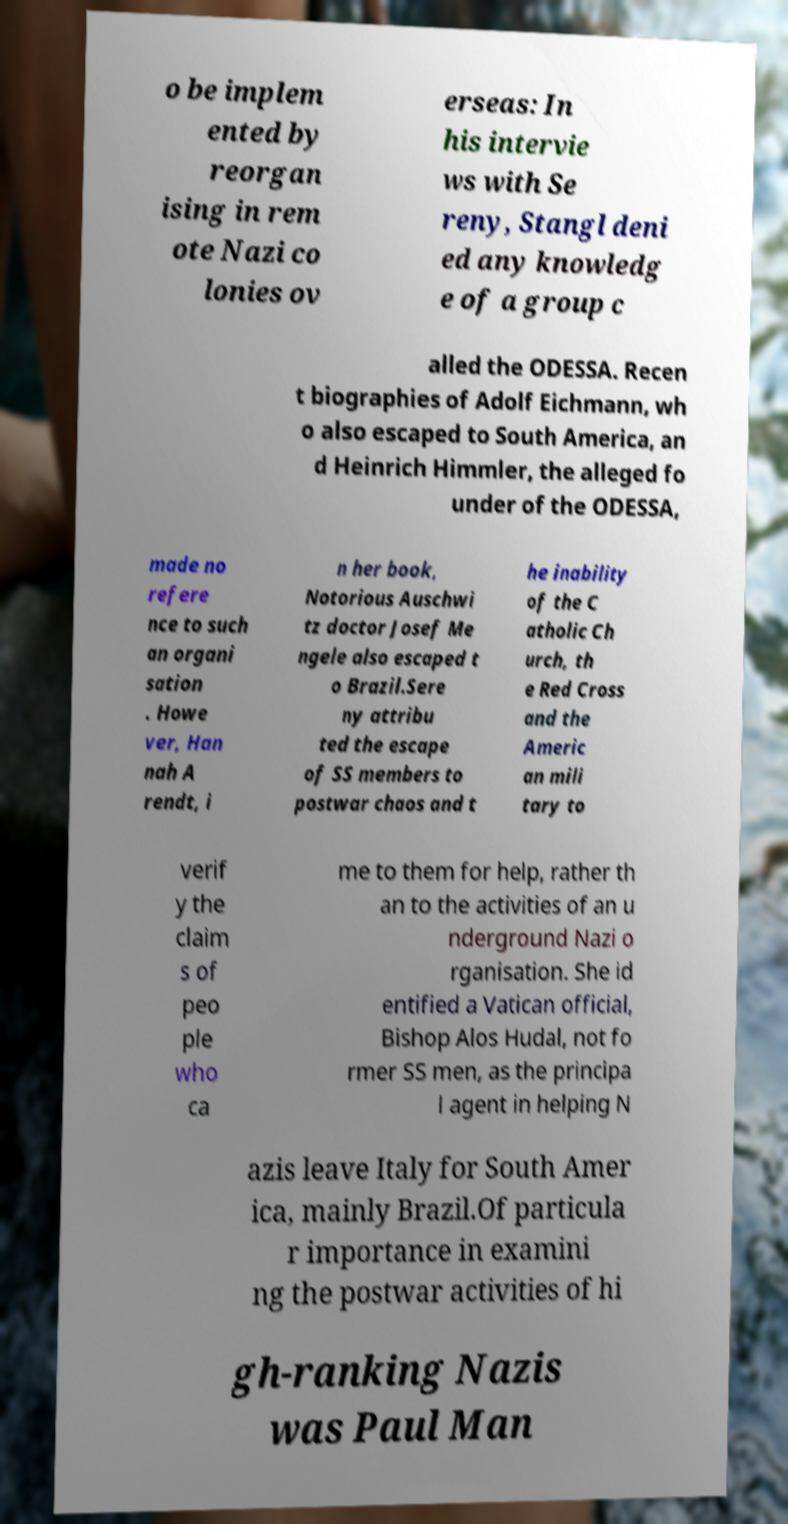Can you read and provide the text displayed in the image?This photo seems to have some interesting text. Can you extract and type it out for me? o be implem ented by reorgan ising in rem ote Nazi co lonies ov erseas: In his intervie ws with Se reny, Stangl deni ed any knowledg e of a group c alled the ODESSA. Recen t biographies of Adolf Eichmann, wh o also escaped to South America, an d Heinrich Himmler, the alleged fo under of the ODESSA, made no refere nce to such an organi sation . Howe ver, Han nah A rendt, i n her book, Notorious Auschwi tz doctor Josef Me ngele also escaped t o Brazil.Sere ny attribu ted the escape of SS members to postwar chaos and t he inability of the C atholic Ch urch, th e Red Cross and the Americ an mili tary to verif y the claim s of peo ple who ca me to them for help, rather th an to the activities of an u nderground Nazi o rganisation. She id entified a Vatican official, Bishop Alos Hudal, not fo rmer SS men, as the principa l agent in helping N azis leave Italy for South Amer ica, mainly Brazil.Of particula r importance in examini ng the postwar activities of hi gh-ranking Nazis was Paul Man 